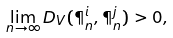<formula> <loc_0><loc_0><loc_500><loc_500>\lim _ { n \to \infty } D _ { V } ( \P _ { n } ^ { i } , \P _ { n } ^ { j } ) > 0 ,</formula> 